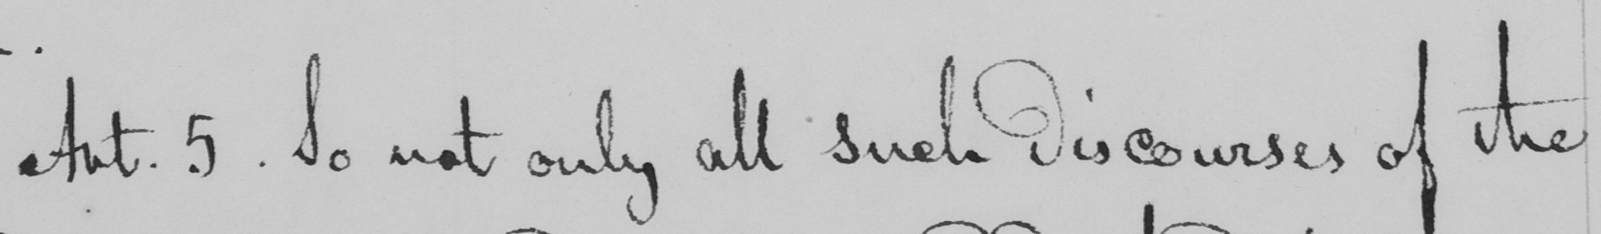What does this handwritten line say? Art . 5 . So not only all such discourses of the 